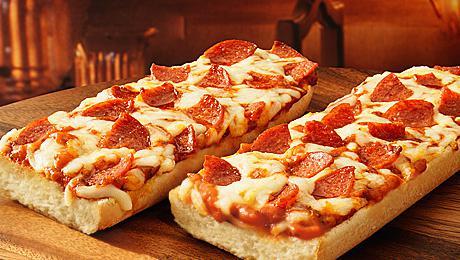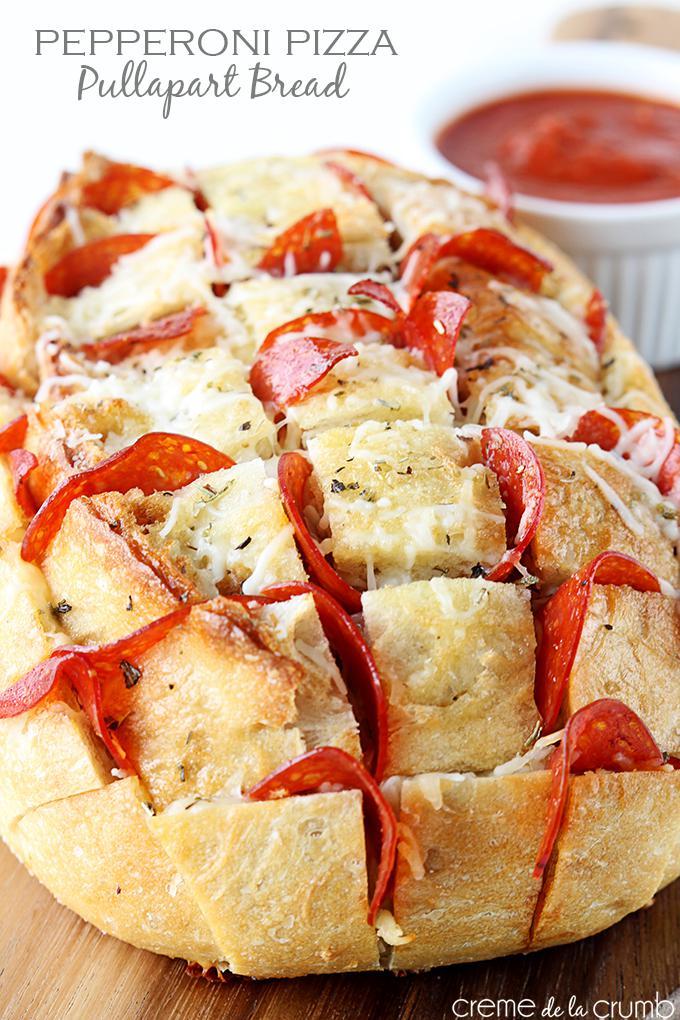The first image is the image on the left, the second image is the image on the right. Given the left and right images, does the statement "In at least one image there is pepperoni pizza bread with marinara sauce to the left of the bread." hold true? Answer yes or no. No. The first image is the image on the left, the second image is the image on the right. Considering the images on both sides, is "The right image shows an oblong loaf with pepperoni sticking out of criss-cross cuts, and the left image includes at least one rectangular shape with pepperonis and melted cheese on top." valid? Answer yes or no. Yes. 